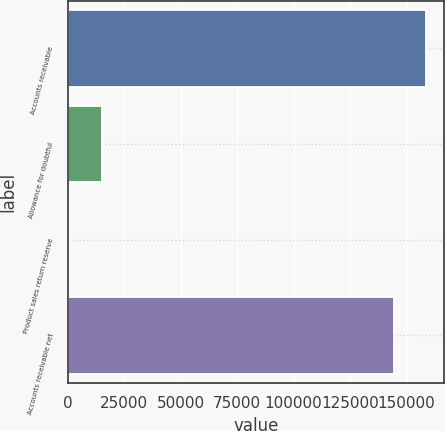<chart> <loc_0><loc_0><loc_500><loc_500><bar_chart><fcel>Accounts receivable<fcel>Allowance for doubtful<fcel>Product sales return reserve<fcel>Accounts receivable net<nl><fcel>158786<fcel>15088.6<fcel>566<fcel>144263<nl></chart> 